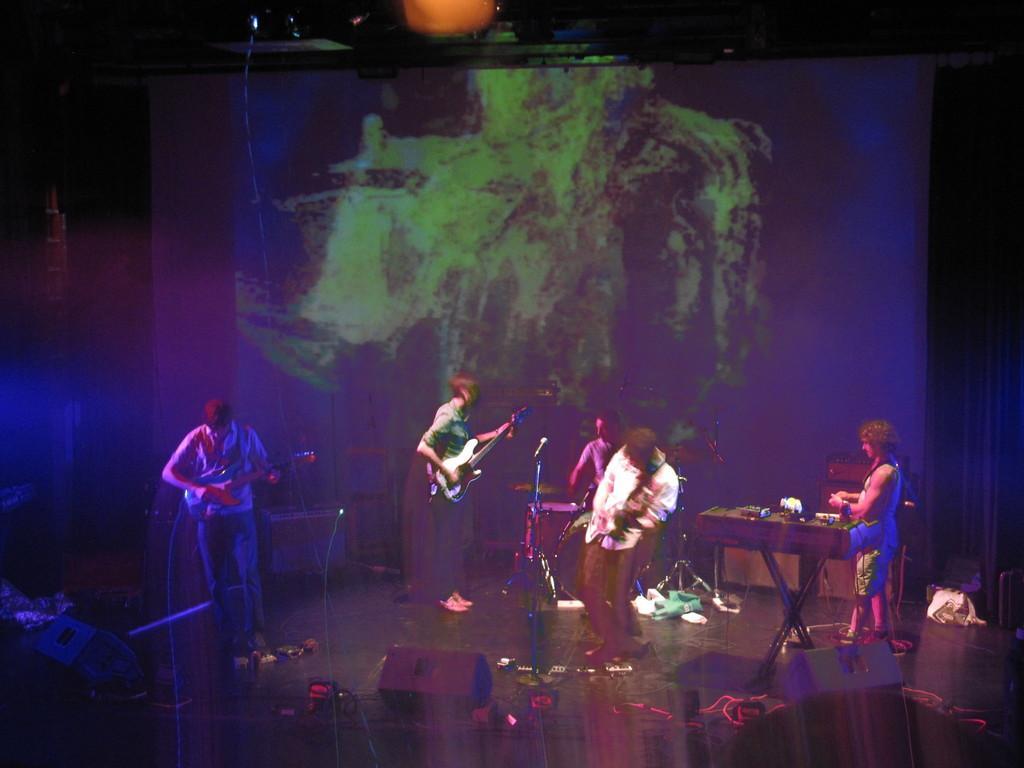Could you give a brief overview of what you see in this image? In this image there are 3 persons standing and playing a guitar, another person sitting and playing drums ,another man standing near the piano ,and back ground there is a screen. 